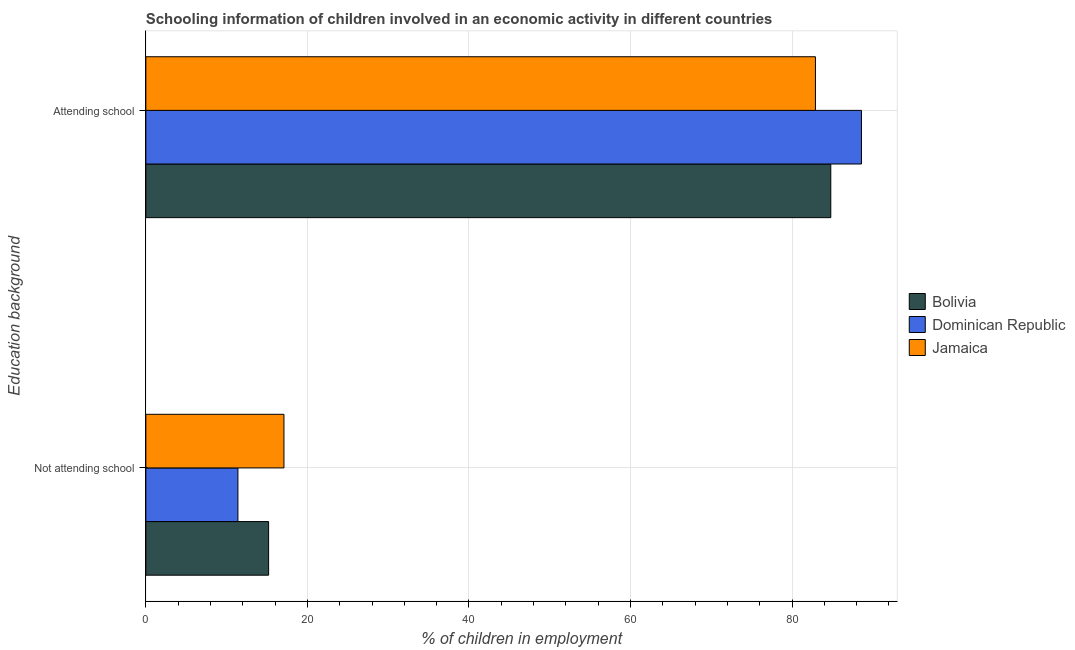Are the number of bars on each tick of the Y-axis equal?
Provide a short and direct response. Yes. How many bars are there on the 1st tick from the top?
Ensure brevity in your answer.  3. How many bars are there on the 1st tick from the bottom?
Ensure brevity in your answer.  3. What is the label of the 2nd group of bars from the top?
Give a very brief answer. Not attending school. What is the percentage of employed children who are attending school in Bolivia?
Provide a succinct answer. 84.8. Across all countries, what is the maximum percentage of employed children who are attending school?
Give a very brief answer. 88.6. Across all countries, what is the minimum percentage of employed children who are attending school?
Offer a very short reply. 82.9. In which country was the percentage of employed children who are attending school maximum?
Offer a terse response. Dominican Republic. In which country was the percentage of employed children who are attending school minimum?
Your answer should be very brief. Jamaica. What is the total percentage of employed children who are attending school in the graph?
Offer a very short reply. 256.3. What is the difference between the percentage of employed children who are not attending school in Jamaica and that in Bolivia?
Your response must be concise. 1.9. What is the difference between the percentage of employed children who are not attending school in Dominican Republic and the percentage of employed children who are attending school in Bolivia?
Provide a succinct answer. -73.4. What is the average percentage of employed children who are not attending school per country?
Ensure brevity in your answer.  14.57. What is the difference between the percentage of employed children who are attending school and percentage of employed children who are not attending school in Dominican Republic?
Your answer should be very brief. 77.2. In how many countries, is the percentage of employed children who are attending school greater than 48 %?
Ensure brevity in your answer.  3. What is the ratio of the percentage of employed children who are not attending school in Bolivia to that in Jamaica?
Make the answer very short. 0.89. Is the percentage of employed children who are attending school in Jamaica less than that in Dominican Republic?
Offer a very short reply. Yes. What does the 1st bar from the top in Not attending school represents?
Your response must be concise. Jamaica. What does the 1st bar from the bottom in Not attending school represents?
Your answer should be very brief. Bolivia. How many bars are there?
Your answer should be very brief. 6. Are the values on the major ticks of X-axis written in scientific E-notation?
Provide a short and direct response. No. Does the graph contain any zero values?
Ensure brevity in your answer.  No. How many legend labels are there?
Keep it short and to the point. 3. What is the title of the graph?
Provide a short and direct response. Schooling information of children involved in an economic activity in different countries. Does "Nigeria" appear as one of the legend labels in the graph?
Your response must be concise. No. What is the label or title of the X-axis?
Offer a terse response. % of children in employment. What is the label or title of the Y-axis?
Provide a short and direct response. Education background. What is the % of children in employment in Bolivia in Not attending school?
Ensure brevity in your answer.  15.2. What is the % of children in employment in Dominican Republic in Not attending school?
Your response must be concise. 11.4. What is the % of children in employment of Bolivia in Attending school?
Make the answer very short. 84.8. What is the % of children in employment of Dominican Republic in Attending school?
Keep it short and to the point. 88.6. What is the % of children in employment in Jamaica in Attending school?
Your response must be concise. 82.9. Across all Education background, what is the maximum % of children in employment of Bolivia?
Ensure brevity in your answer.  84.8. Across all Education background, what is the maximum % of children in employment in Dominican Republic?
Give a very brief answer. 88.6. Across all Education background, what is the maximum % of children in employment of Jamaica?
Keep it short and to the point. 82.9. What is the difference between the % of children in employment in Bolivia in Not attending school and that in Attending school?
Make the answer very short. -69.6. What is the difference between the % of children in employment in Dominican Republic in Not attending school and that in Attending school?
Keep it short and to the point. -77.2. What is the difference between the % of children in employment in Jamaica in Not attending school and that in Attending school?
Your answer should be very brief. -65.8. What is the difference between the % of children in employment of Bolivia in Not attending school and the % of children in employment of Dominican Republic in Attending school?
Give a very brief answer. -73.4. What is the difference between the % of children in employment in Bolivia in Not attending school and the % of children in employment in Jamaica in Attending school?
Make the answer very short. -67.7. What is the difference between the % of children in employment in Dominican Republic in Not attending school and the % of children in employment in Jamaica in Attending school?
Keep it short and to the point. -71.5. What is the average % of children in employment in Dominican Republic per Education background?
Provide a short and direct response. 50. What is the difference between the % of children in employment of Bolivia and % of children in employment of Dominican Republic in Not attending school?
Offer a very short reply. 3.8. What is the difference between the % of children in employment of Bolivia and % of children in employment of Jamaica in Not attending school?
Provide a short and direct response. -1.9. What is the difference between the % of children in employment of Dominican Republic and % of children in employment of Jamaica in Not attending school?
Your answer should be very brief. -5.7. What is the difference between the % of children in employment of Bolivia and % of children in employment of Dominican Republic in Attending school?
Your answer should be very brief. -3.8. What is the ratio of the % of children in employment in Bolivia in Not attending school to that in Attending school?
Your answer should be very brief. 0.18. What is the ratio of the % of children in employment in Dominican Republic in Not attending school to that in Attending school?
Keep it short and to the point. 0.13. What is the ratio of the % of children in employment of Jamaica in Not attending school to that in Attending school?
Provide a succinct answer. 0.21. What is the difference between the highest and the second highest % of children in employment in Bolivia?
Keep it short and to the point. 69.6. What is the difference between the highest and the second highest % of children in employment of Dominican Republic?
Offer a very short reply. 77.2. What is the difference between the highest and the second highest % of children in employment in Jamaica?
Give a very brief answer. 65.8. What is the difference between the highest and the lowest % of children in employment in Bolivia?
Offer a terse response. 69.6. What is the difference between the highest and the lowest % of children in employment of Dominican Republic?
Your answer should be compact. 77.2. What is the difference between the highest and the lowest % of children in employment of Jamaica?
Make the answer very short. 65.8. 